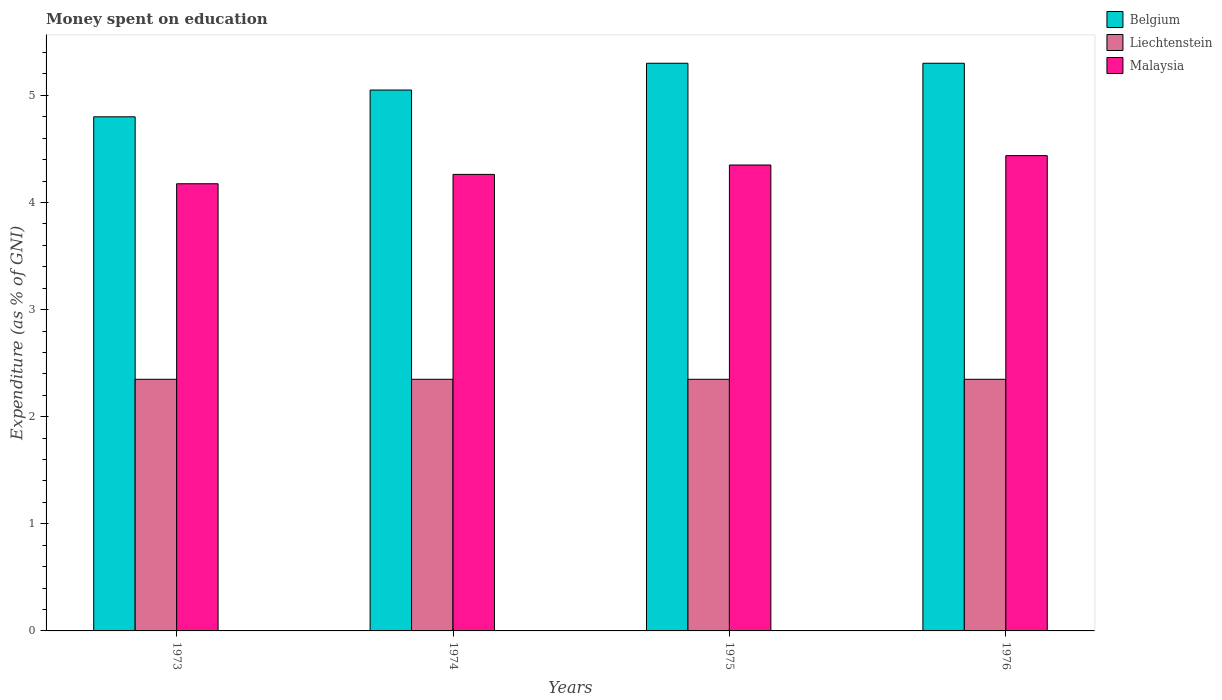How many groups of bars are there?
Give a very brief answer. 4. How many bars are there on the 1st tick from the right?
Keep it short and to the point. 3. What is the label of the 3rd group of bars from the left?
Ensure brevity in your answer.  1975. What is the amount of money spent on education in Belgium in 1974?
Make the answer very short. 5.05. Across all years, what is the minimum amount of money spent on education in Malaysia?
Provide a short and direct response. 4.17. What is the total amount of money spent on education in Liechtenstein in the graph?
Your response must be concise. 9.4. What is the difference between the amount of money spent on education in Malaysia in 1974 and that in 1976?
Ensure brevity in your answer.  -0.18. What is the difference between the amount of money spent on education in Belgium in 1973 and the amount of money spent on education in Liechtenstein in 1976?
Give a very brief answer. 2.45. What is the average amount of money spent on education in Liechtenstein per year?
Your answer should be very brief. 2.35. In the year 1976, what is the difference between the amount of money spent on education in Liechtenstein and amount of money spent on education in Malaysia?
Offer a very short reply. -2.09. What is the ratio of the amount of money spent on education in Liechtenstein in 1973 to that in 1974?
Provide a succinct answer. 1. Is the difference between the amount of money spent on education in Liechtenstein in 1973 and 1975 greater than the difference between the amount of money spent on education in Malaysia in 1973 and 1975?
Make the answer very short. Yes. What is the difference between the highest and the second highest amount of money spent on education in Malaysia?
Offer a terse response. 0.09. What is the difference between the highest and the lowest amount of money spent on education in Liechtenstein?
Offer a terse response. 0. In how many years, is the amount of money spent on education in Liechtenstein greater than the average amount of money spent on education in Liechtenstein taken over all years?
Provide a short and direct response. 0. Is the sum of the amount of money spent on education in Liechtenstein in 1974 and 1976 greater than the maximum amount of money spent on education in Belgium across all years?
Provide a succinct answer. No. What does the 2nd bar from the left in 1973 represents?
Give a very brief answer. Liechtenstein. Are all the bars in the graph horizontal?
Your answer should be very brief. No. How many years are there in the graph?
Give a very brief answer. 4. Are the values on the major ticks of Y-axis written in scientific E-notation?
Provide a succinct answer. No. Does the graph contain any zero values?
Ensure brevity in your answer.  No. Does the graph contain grids?
Your response must be concise. No. What is the title of the graph?
Your answer should be very brief. Money spent on education. What is the label or title of the X-axis?
Offer a very short reply. Years. What is the label or title of the Y-axis?
Offer a terse response. Expenditure (as % of GNI). What is the Expenditure (as % of GNI) of Liechtenstein in 1973?
Give a very brief answer. 2.35. What is the Expenditure (as % of GNI) of Malaysia in 1973?
Ensure brevity in your answer.  4.17. What is the Expenditure (as % of GNI) in Belgium in 1974?
Offer a terse response. 5.05. What is the Expenditure (as % of GNI) of Liechtenstein in 1974?
Ensure brevity in your answer.  2.35. What is the Expenditure (as % of GNI) in Malaysia in 1974?
Your response must be concise. 4.26. What is the Expenditure (as % of GNI) in Liechtenstein in 1975?
Offer a very short reply. 2.35. What is the Expenditure (as % of GNI) in Malaysia in 1975?
Your answer should be compact. 4.35. What is the Expenditure (as % of GNI) in Liechtenstein in 1976?
Provide a short and direct response. 2.35. What is the Expenditure (as % of GNI) in Malaysia in 1976?
Offer a very short reply. 4.44. Across all years, what is the maximum Expenditure (as % of GNI) of Liechtenstein?
Provide a succinct answer. 2.35. Across all years, what is the maximum Expenditure (as % of GNI) of Malaysia?
Provide a short and direct response. 4.44. Across all years, what is the minimum Expenditure (as % of GNI) in Liechtenstein?
Provide a short and direct response. 2.35. Across all years, what is the minimum Expenditure (as % of GNI) of Malaysia?
Give a very brief answer. 4.17. What is the total Expenditure (as % of GNI) of Belgium in the graph?
Offer a terse response. 20.45. What is the total Expenditure (as % of GNI) of Liechtenstein in the graph?
Offer a very short reply. 9.4. What is the total Expenditure (as % of GNI) of Malaysia in the graph?
Provide a succinct answer. 17.23. What is the difference between the Expenditure (as % of GNI) in Belgium in 1973 and that in 1974?
Make the answer very short. -0.25. What is the difference between the Expenditure (as % of GNI) of Liechtenstein in 1973 and that in 1974?
Ensure brevity in your answer.  0. What is the difference between the Expenditure (as % of GNI) of Malaysia in 1973 and that in 1974?
Make the answer very short. -0.09. What is the difference between the Expenditure (as % of GNI) of Belgium in 1973 and that in 1975?
Your response must be concise. -0.5. What is the difference between the Expenditure (as % of GNI) in Malaysia in 1973 and that in 1975?
Keep it short and to the point. -0.17. What is the difference between the Expenditure (as % of GNI) in Malaysia in 1973 and that in 1976?
Provide a short and direct response. -0.26. What is the difference between the Expenditure (as % of GNI) in Liechtenstein in 1974 and that in 1975?
Offer a very short reply. 0. What is the difference between the Expenditure (as % of GNI) in Malaysia in 1974 and that in 1975?
Your response must be concise. -0.09. What is the difference between the Expenditure (as % of GNI) of Belgium in 1974 and that in 1976?
Provide a succinct answer. -0.25. What is the difference between the Expenditure (as % of GNI) of Liechtenstein in 1974 and that in 1976?
Keep it short and to the point. 0. What is the difference between the Expenditure (as % of GNI) in Malaysia in 1974 and that in 1976?
Your answer should be compact. -0.17. What is the difference between the Expenditure (as % of GNI) of Liechtenstein in 1975 and that in 1976?
Provide a succinct answer. 0. What is the difference between the Expenditure (as % of GNI) in Malaysia in 1975 and that in 1976?
Your answer should be very brief. -0.09. What is the difference between the Expenditure (as % of GNI) of Belgium in 1973 and the Expenditure (as % of GNI) of Liechtenstein in 1974?
Keep it short and to the point. 2.45. What is the difference between the Expenditure (as % of GNI) of Belgium in 1973 and the Expenditure (as % of GNI) of Malaysia in 1974?
Ensure brevity in your answer.  0.54. What is the difference between the Expenditure (as % of GNI) of Liechtenstein in 1973 and the Expenditure (as % of GNI) of Malaysia in 1974?
Give a very brief answer. -1.91. What is the difference between the Expenditure (as % of GNI) in Belgium in 1973 and the Expenditure (as % of GNI) in Liechtenstein in 1975?
Provide a short and direct response. 2.45. What is the difference between the Expenditure (as % of GNI) in Belgium in 1973 and the Expenditure (as % of GNI) in Malaysia in 1975?
Keep it short and to the point. 0.45. What is the difference between the Expenditure (as % of GNI) in Liechtenstein in 1973 and the Expenditure (as % of GNI) in Malaysia in 1975?
Your response must be concise. -2. What is the difference between the Expenditure (as % of GNI) in Belgium in 1973 and the Expenditure (as % of GNI) in Liechtenstein in 1976?
Your answer should be very brief. 2.45. What is the difference between the Expenditure (as % of GNI) of Belgium in 1973 and the Expenditure (as % of GNI) of Malaysia in 1976?
Your answer should be compact. 0.36. What is the difference between the Expenditure (as % of GNI) of Liechtenstein in 1973 and the Expenditure (as % of GNI) of Malaysia in 1976?
Provide a succinct answer. -2.09. What is the difference between the Expenditure (as % of GNI) of Belgium in 1974 and the Expenditure (as % of GNI) of Liechtenstein in 1975?
Make the answer very short. 2.7. What is the difference between the Expenditure (as % of GNI) of Belgium in 1974 and the Expenditure (as % of GNI) of Malaysia in 1975?
Your answer should be compact. 0.7. What is the difference between the Expenditure (as % of GNI) of Liechtenstein in 1974 and the Expenditure (as % of GNI) of Malaysia in 1975?
Give a very brief answer. -2. What is the difference between the Expenditure (as % of GNI) in Belgium in 1974 and the Expenditure (as % of GNI) in Liechtenstein in 1976?
Offer a very short reply. 2.7. What is the difference between the Expenditure (as % of GNI) in Belgium in 1974 and the Expenditure (as % of GNI) in Malaysia in 1976?
Your response must be concise. 0.61. What is the difference between the Expenditure (as % of GNI) in Liechtenstein in 1974 and the Expenditure (as % of GNI) in Malaysia in 1976?
Offer a terse response. -2.09. What is the difference between the Expenditure (as % of GNI) in Belgium in 1975 and the Expenditure (as % of GNI) in Liechtenstein in 1976?
Your answer should be compact. 2.95. What is the difference between the Expenditure (as % of GNI) of Belgium in 1975 and the Expenditure (as % of GNI) of Malaysia in 1976?
Provide a short and direct response. 0.86. What is the difference between the Expenditure (as % of GNI) in Liechtenstein in 1975 and the Expenditure (as % of GNI) in Malaysia in 1976?
Offer a terse response. -2.09. What is the average Expenditure (as % of GNI) of Belgium per year?
Your answer should be very brief. 5.11. What is the average Expenditure (as % of GNI) in Liechtenstein per year?
Offer a terse response. 2.35. What is the average Expenditure (as % of GNI) of Malaysia per year?
Keep it short and to the point. 4.31. In the year 1973, what is the difference between the Expenditure (as % of GNI) of Belgium and Expenditure (as % of GNI) of Liechtenstein?
Provide a succinct answer. 2.45. In the year 1973, what is the difference between the Expenditure (as % of GNI) in Belgium and Expenditure (as % of GNI) in Malaysia?
Make the answer very short. 0.62. In the year 1973, what is the difference between the Expenditure (as % of GNI) of Liechtenstein and Expenditure (as % of GNI) of Malaysia?
Offer a very short reply. -1.83. In the year 1974, what is the difference between the Expenditure (as % of GNI) of Belgium and Expenditure (as % of GNI) of Liechtenstein?
Offer a terse response. 2.7. In the year 1974, what is the difference between the Expenditure (as % of GNI) of Belgium and Expenditure (as % of GNI) of Malaysia?
Your answer should be compact. 0.79. In the year 1974, what is the difference between the Expenditure (as % of GNI) in Liechtenstein and Expenditure (as % of GNI) in Malaysia?
Your response must be concise. -1.91. In the year 1975, what is the difference between the Expenditure (as % of GNI) in Belgium and Expenditure (as % of GNI) in Liechtenstein?
Ensure brevity in your answer.  2.95. In the year 1975, what is the difference between the Expenditure (as % of GNI) of Belgium and Expenditure (as % of GNI) of Malaysia?
Offer a terse response. 0.95. In the year 1975, what is the difference between the Expenditure (as % of GNI) of Liechtenstein and Expenditure (as % of GNI) of Malaysia?
Make the answer very short. -2. In the year 1976, what is the difference between the Expenditure (as % of GNI) in Belgium and Expenditure (as % of GNI) in Liechtenstein?
Give a very brief answer. 2.95. In the year 1976, what is the difference between the Expenditure (as % of GNI) in Belgium and Expenditure (as % of GNI) in Malaysia?
Keep it short and to the point. 0.86. In the year 1976, what is the difference between the Expenditure (as % of GNI) in Liechtenstein and Expenditure (as % of GNI) in Malaysia?
Your answer should be compact. -2.09. What is the ratio of the Expenditure (as % of GNI) in Belgium in 1973 to that in 1974?
Provide a succinct answer. 0.95. What is the ratio of the Expenditure (as % of GNI) of Malaysia in 1973 to that in 1974?
Make the answer very short. 0.98. What is the ratio of the Expenditure (as % of GNI) in Belgium in 1973 to that in 1975?
Your answer should be compact. 0.91. What is the ratio of the Expenditure (as % of GNI) of Liechtenstein in 1973 to that in 1975?
Offer a very short reply. 1. What is the ratio of the Expenditure (as % of GNI) in Malaysia in 1973 to that in 1975?
Keep it short and to the point. 0.96. What is the ratio of the Expenditure (as % of GNI) in Belgium in 1973 to that in 1976?
Offer a very short reply. 0.91. What is the ratio of the Expenditure (as % of GNI) of Malaysia in 1973 to that in 1976?
Provide a succinct answer. 0.94. What is the ratio of the Expenditure (as % of GNI) of Belgium in 1974 to that in 1975?
Keep it short and to the point. 0.95. What is the ratio of the Expenditure (as % of GNI) of Liechtenstein in 1974 to that in 1975?
Give a very brief answer. 1. What is the ratio of the Expenditure (as % of GNI) in Malaysia in 1974 to that in 1975?
Your answer should be compact. 0.98. What is the ratio of the Expenditure (as % of GNI) of Belgium in 1974 to that in 1976?
Your answer should be compact. 0.95. What is the ratio of the Expenditure (as % of GNI) of Malaysia in 1974 to that in 1976?
Offer a terse response. 0.96. What is the ratio of the Expenditure (as % of GNI) in Belgium in 1975 to that in 1976?
Provide a succinct answer. 1. What is the ratio of the Expenditure (as % of GNI) of Malaysia in 1975 to that in 1976?
Your response must be concise. 0.98. What is the difference between the highest and the second highest Expenditure (as % of GNI) of Liechtenstein?
Ensure brevity in your answer.  0. What is the difference between the highest and the second highest Expenditure (as % of GNI) of Malaysia?
Offer a terse response. 0.09. What is the difference between the highest and the lowest Expenditure (as % of GNI) in Malaysia?
Provide a short and direct response. 0.26. 